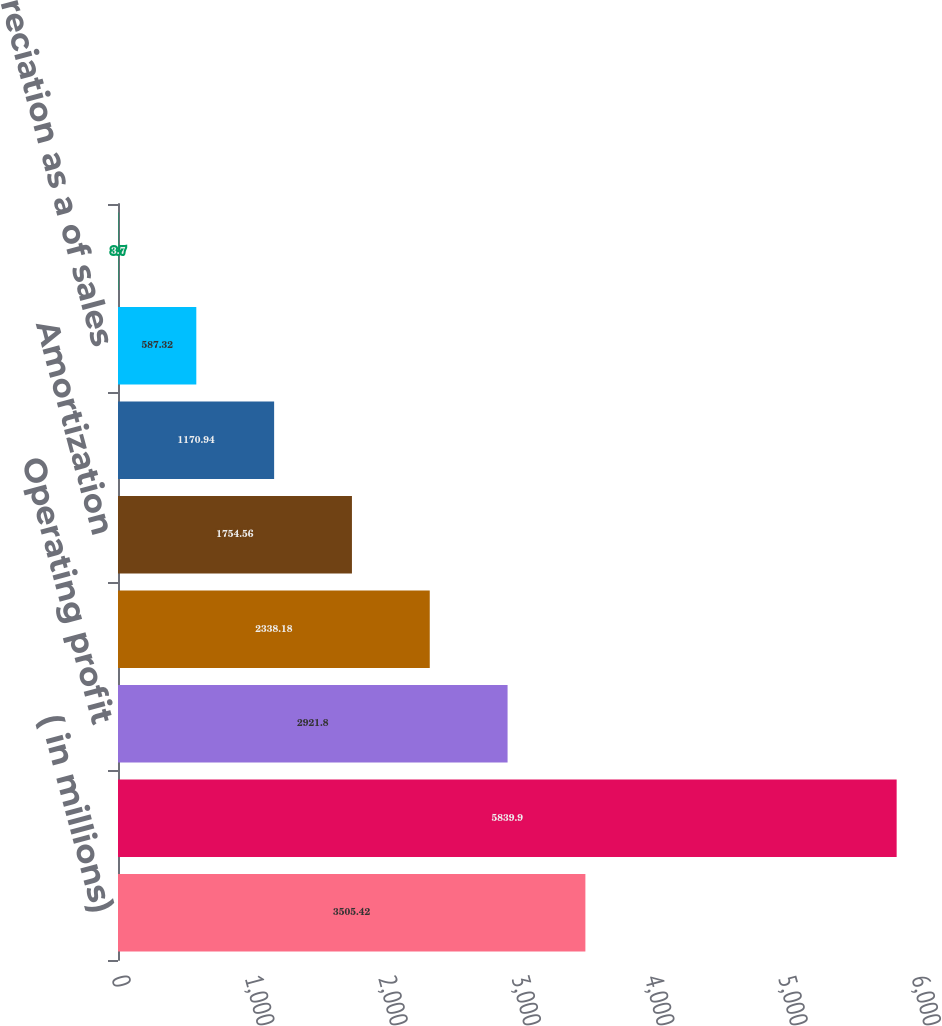<chart> <loc_0><loc_0><loc_500><loc_500><bar_chart><fcel>( in millions)<fcel>Sales<fcel>Operating profit<fcel>Depreciation<fcel>Amortization<fcel>Operating profit as a of sales<fcel>Depreciation as a of sales<fcel>Amortization as a of sales<nl><fcel>3505.42<fcel>5839.9<fcel>2921.8<fcel>2338.18<fcel>1754.56<fcel>1170.94<fcel>587.32<fcel>3.7<nl></chart> 